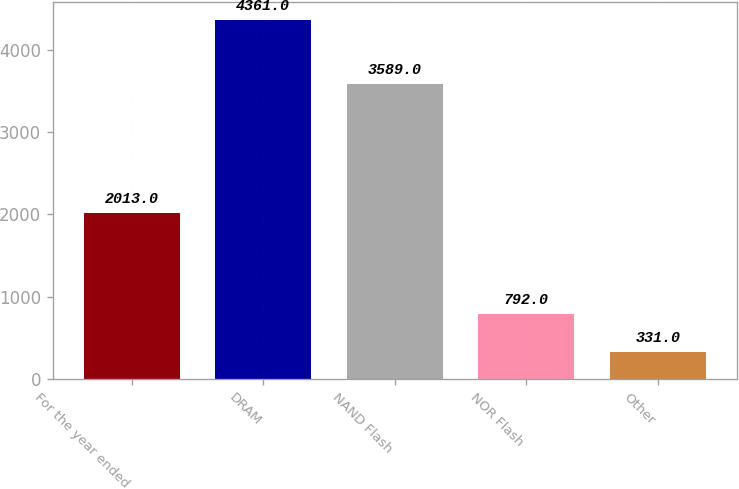<chart> <loc_0><loc_0><loc_500><loc_500><bar_chart><fcel>For the year ended<fcel>DRAM<fcel>NAND Flash<fcel>NOR Flash<fcel>Other<nl><fcel>2013<fcel>4361<fcel>3589<fcel>792<fcel>331<nl></chart> 